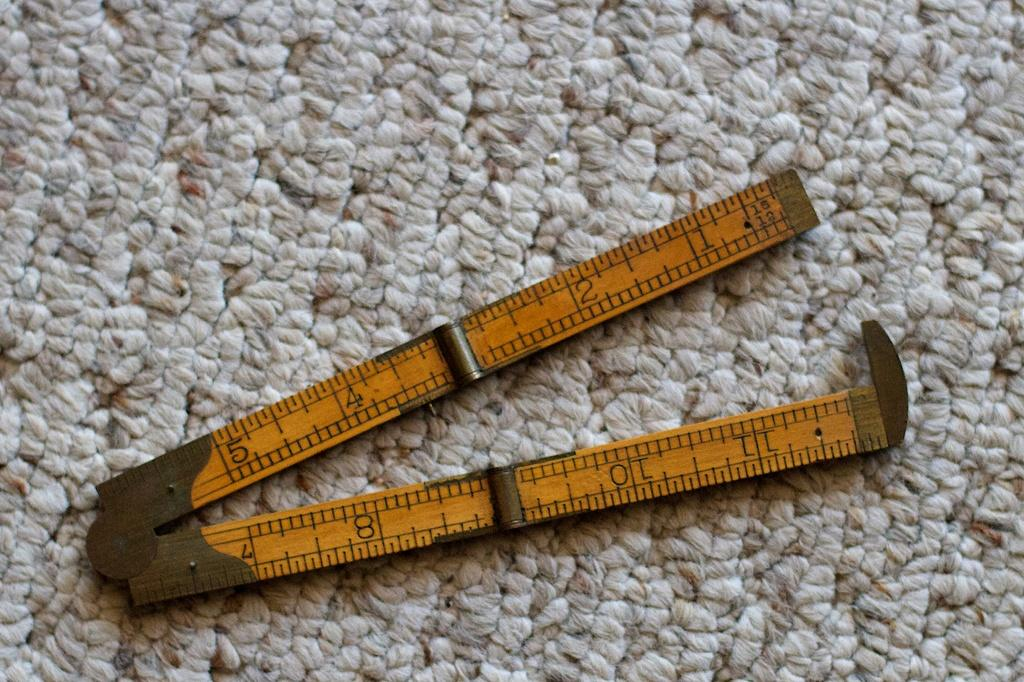<image>
Share a concise interpretation of the image provided. Measuring object on a carpet that has the number 11 on it. 